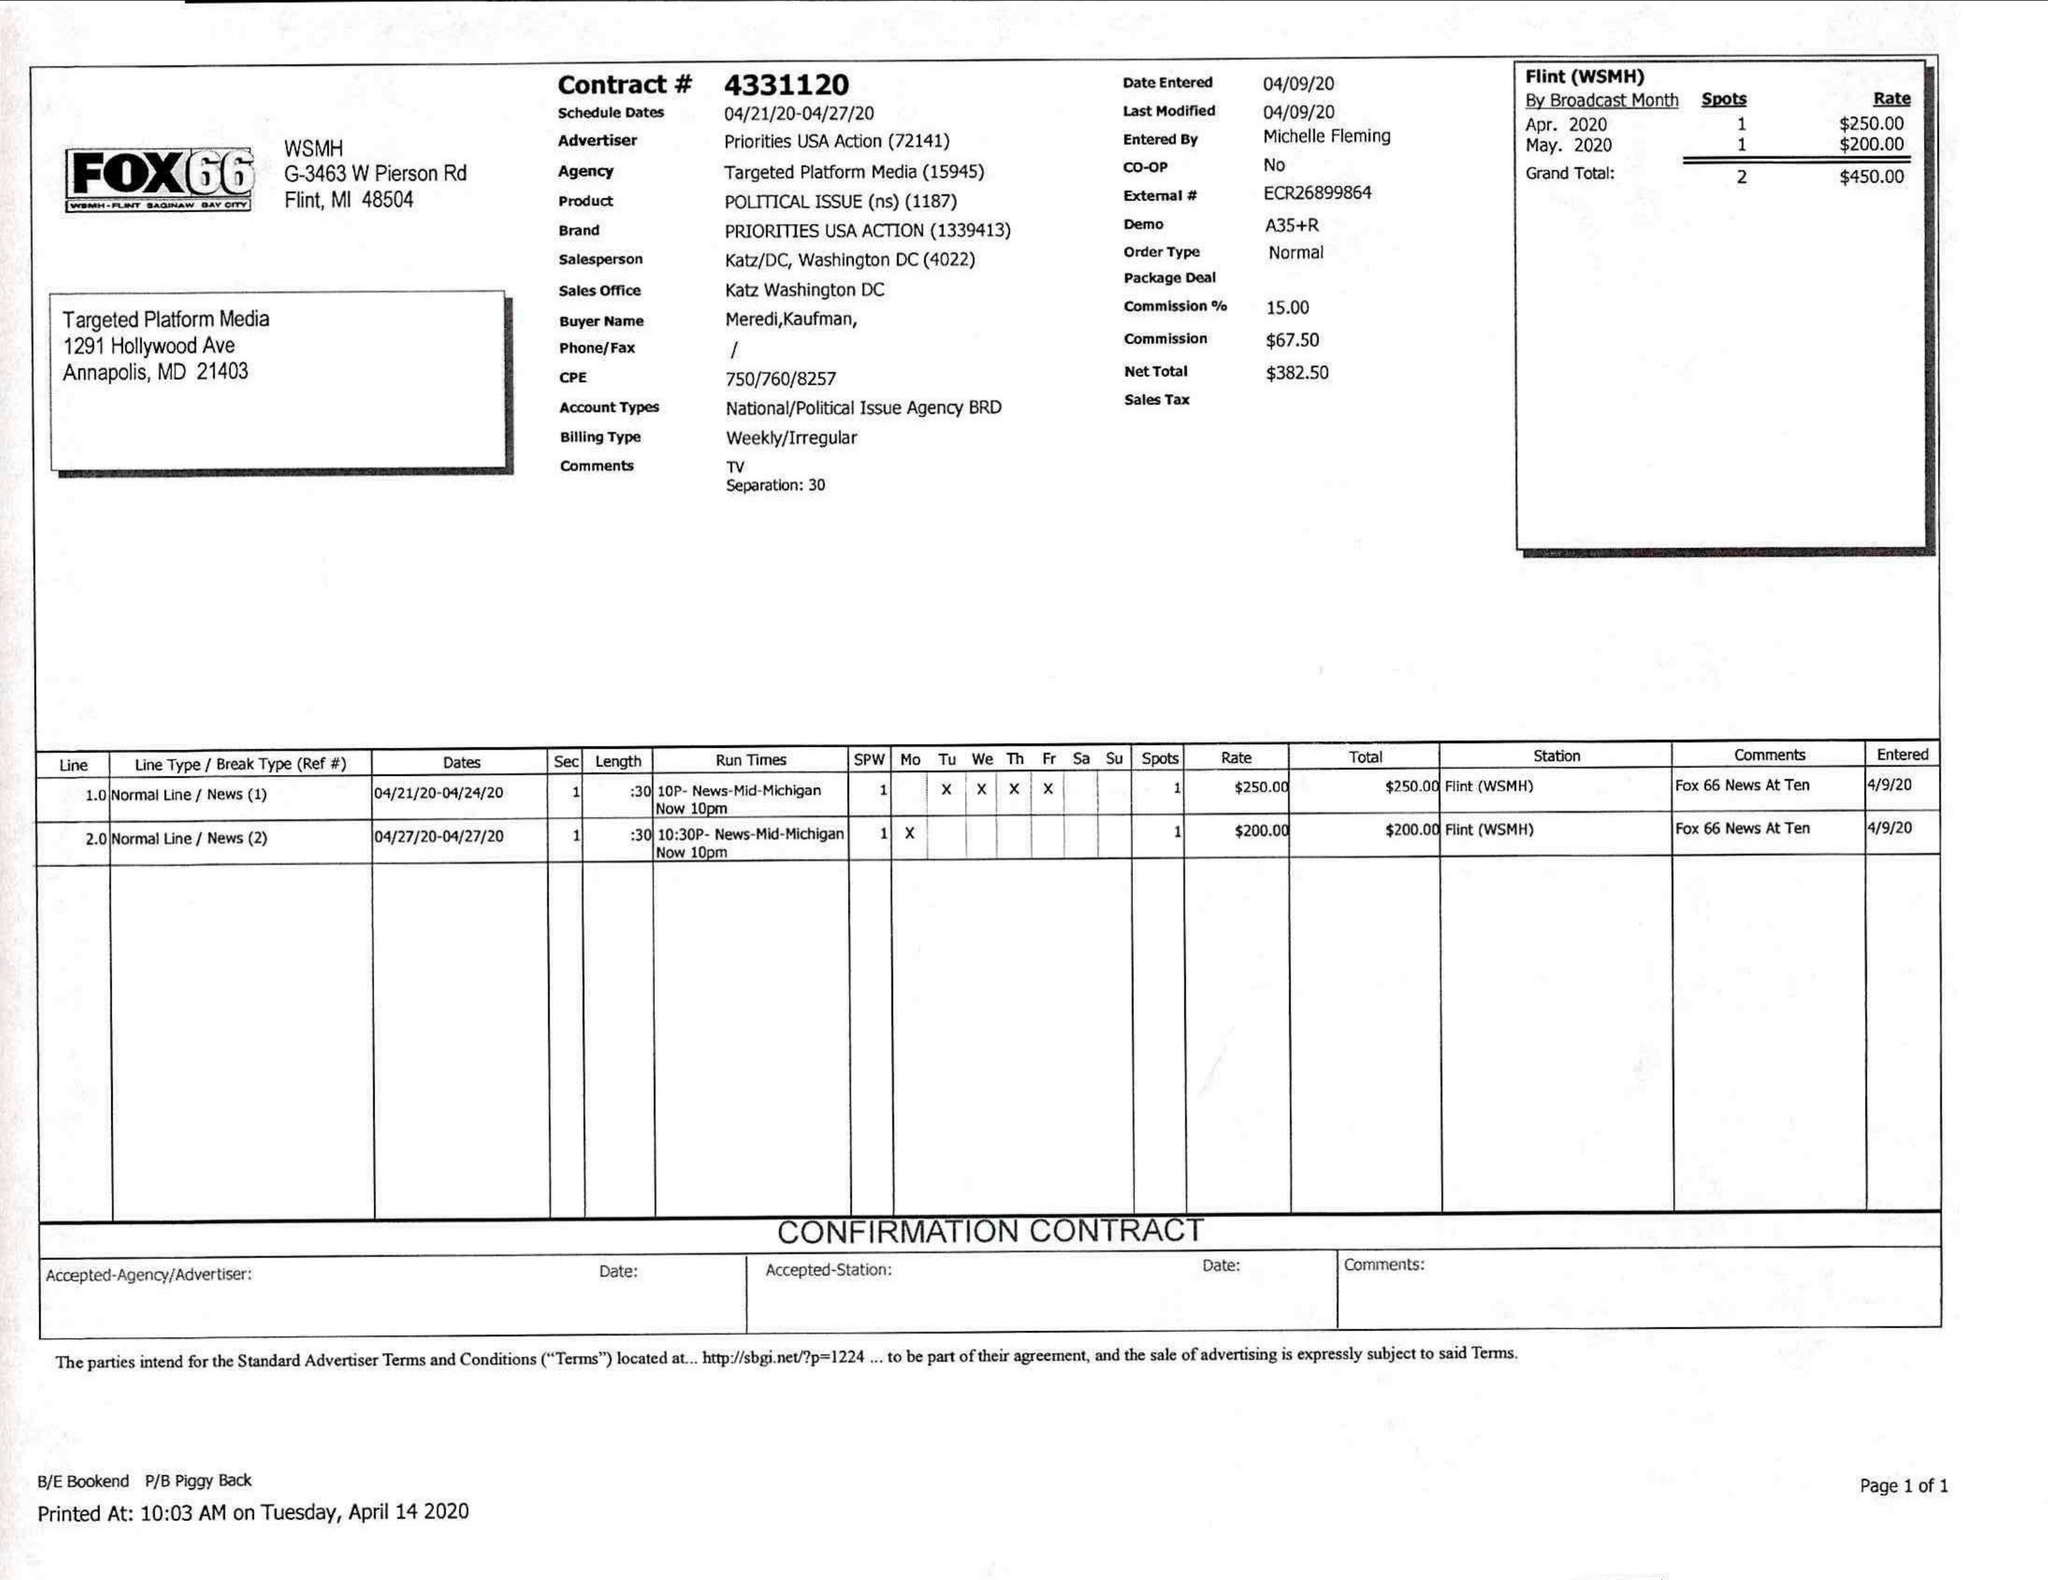What is the value for the contract_num?
Answer the question using a single word or phrase. 4331120 